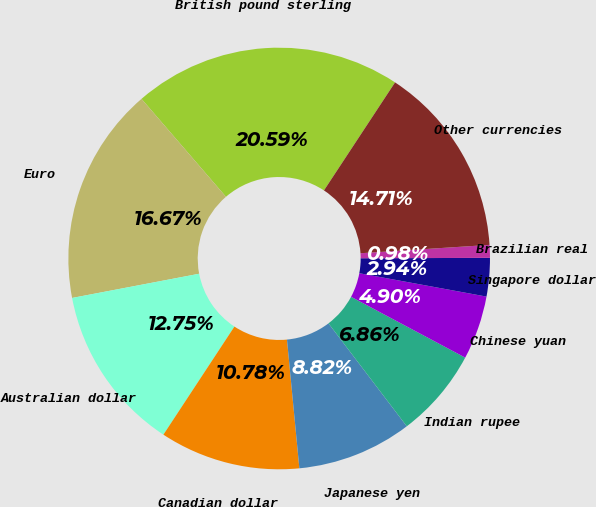Convert chart to OTSL. <chart><loc_0><loc_0><loc_500><loc_500><pie_chart><fcel>British pound sterling<fcel>Euro<fcel>Australian dollar<fcel>Canadian dollar<fcel>Japanese yen<fcel>Indian rupee<fcel>Chinese yuan<fcel>Singapore dollar<fcel>Brazilian real<fcel>Other currencies<nl><fcel>20.59%<fcel>16.67%<fcel>12.75%<fcel>10.78%<fcel>8.82%<fcel>6.86%<fcel>4.9%<fcel>2.94%<fcel>0.98%<fcel>14.71%<nl></chart> 